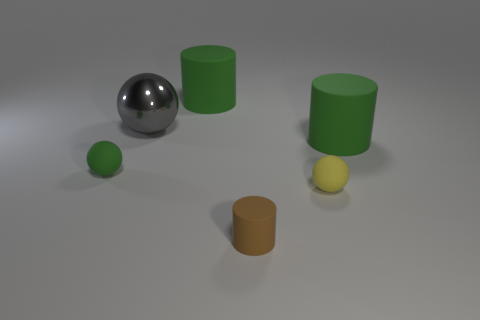Subtract all rubber balls. How many balls are left? 1 Subtract 2 spheres. How many spheres are left? 1 Subtract all yellow spheres. How many gray cylinders are left? 0 Subtract all large rubber objects. Subtract all large rubber cylinders. How many objects are left? 2 Add 1 large green matte cylinders. How many large green matte cylinders are left? 3 Add 3 small green matte balls. How many small green matte balls exist? 4 Add 1 tiny balls. How many objects exist? 7 Subtract all gray spheres. How many spheres are left? 2 Subtract 1 green balls. How many objects are left? 5 Subtract all blue cylinders. Subtract all yellow spheres. How many cylinders are left? 3 